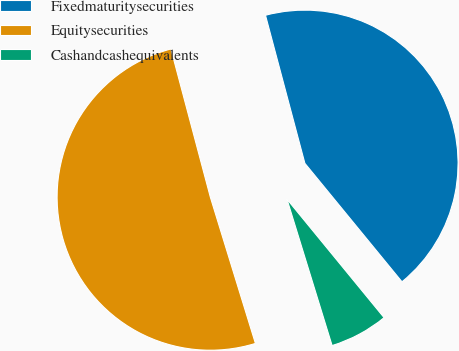Convert chart. <chart><loc_0><loc_0><loc_500><loc_500><pie_chart><fcel>Fixedmaturitysecurities<fcel>Equitysecurities<fcel>Cashandcashequivalents<nl><fcel>43.21%<fcel>50.62%<fcel>6.17%<nl></chart> 